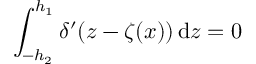<formula> <loc_0><loc_0><loc_500><loc_500>\int _ { - h _ { 2 } } ^ { h _ { 1 } } \delta ^ { \prime } ( z - \zeta ( x ) ) \, d z = 0</formula> 